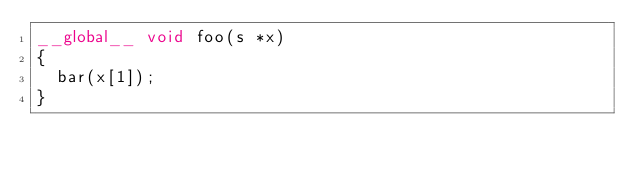Convert code to text. <code><loc_0><loc_0><loc_500><loc_500><_Cuda_>__global__ void foo(s *x)
{
  bar(x[1]);
}
</code> 